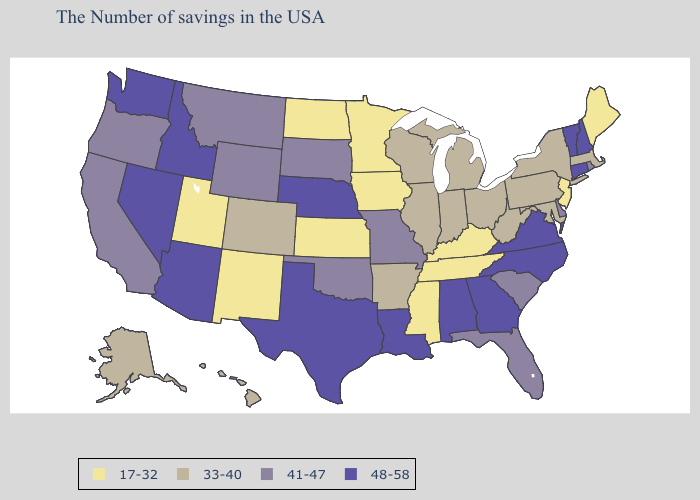Name the states that have a value in the range 48-58?
Give a very brief answer. New Hampshire, Vermont, Connecticut, Virginia, North Carolina, Georgia, Alabama, Louisiana, Nebraska, Texas, Arizona, Idaho, Nevada, Washington. What is the highest value in the USA?
Give a very brief answer. 48-58. Does Alaska have a lower value than Rhode Island?
Give a very brief answer. Yes. Name the states that have a value in the range 41-47?
Short answer required. Rhode Island, Delaware, South Carolina, Florida, Missouri, Oklahoma, South Dakota, Wyoming, Montana, California, Oregon. Among the states that border Idaho , does Oregon have the lowest value?
Be succinct. No. Among the states that border New Mexico , which have the lowest value?
Answer briefly. Utah. Name the states that have a value in the range 17-32?
Concise answer only. Maine, New Jersey, Kentucky, Tennessee, Mississippi, Minnesota, Iowa, Kansas, North Dakota, New Mexico, Utah. Does Massachusetts have the lowest value in the USA?
Concise answer only. No. Name the states that have a value in the range 41-47?
Write a very short answer. Rhode Island, Delaware, South Carolina, Florida, Missouri, Oklahoma, South Dakota, Wyoming, Montana, California, Oregon. Name the states that have a value in the range 48-58?
Short answer required. New Hampshire, Vermont, Connecticut, Virginia, North Carolina, Georgia, Alabama, Louisiana, Nebraska, Texas, Arizona, Idaho, Nevada, Washington. What is the lowest value in the USA?
Short answer required. 17-32. What is the value of Florida?
Short answer required. 41-47. What is the highest value in states that border New Hampshire?
Give a very brief answer. 48-58. Does the map have missing data?
Short answer required. No. What is the lowest value in states that border Wisconsin?
Quick response, please. 17-32. 